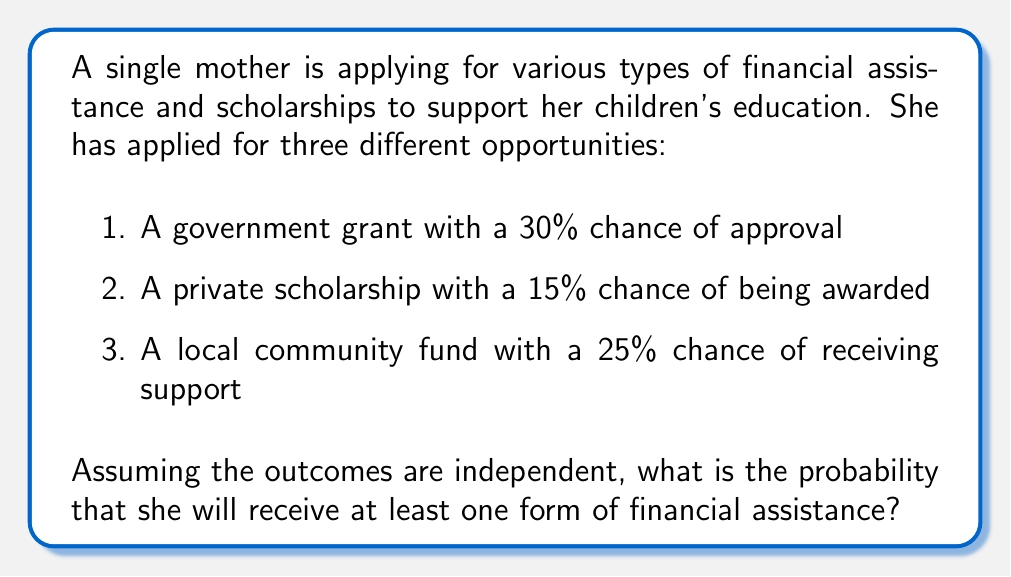Give your solution to this math problem. To solve this problem, we'll use the concept of probability of complementary events from information theory. We'll follow these steps:

1. Calculate the probability of not receiving each type of assistance:
   - Government grant: $1 - 0.30 = 0.70$
   - Private scholarship: $1 - 0.15 = 0.85$
   - Local community fund: $1 - 0.25 = 0.75$

2. Calculate the probability of not receiving any assistance:
   Since the events are independent, we multiply these probabilities:
   $$P(\text{no assistance}) = 0.70 \times 0.85 \times 0.75 = 0.44625$$

3. The probability of receiving at least one form of assistance is the complement of receiving no assistance:
   $$P(\text{at least one}) = 1 - P(\text{no assistance})$$
   $$P(\text{at least one}) = 1 - 0.44625 = 0.55375$$

4. Convert the result to a percentage:
   $$0.55375 \times 100\% = 55.375\%$$

Therefore, the single mother has a 55.375% chance of receiving at least one form of financial assistance.
Answer: 55.375% 